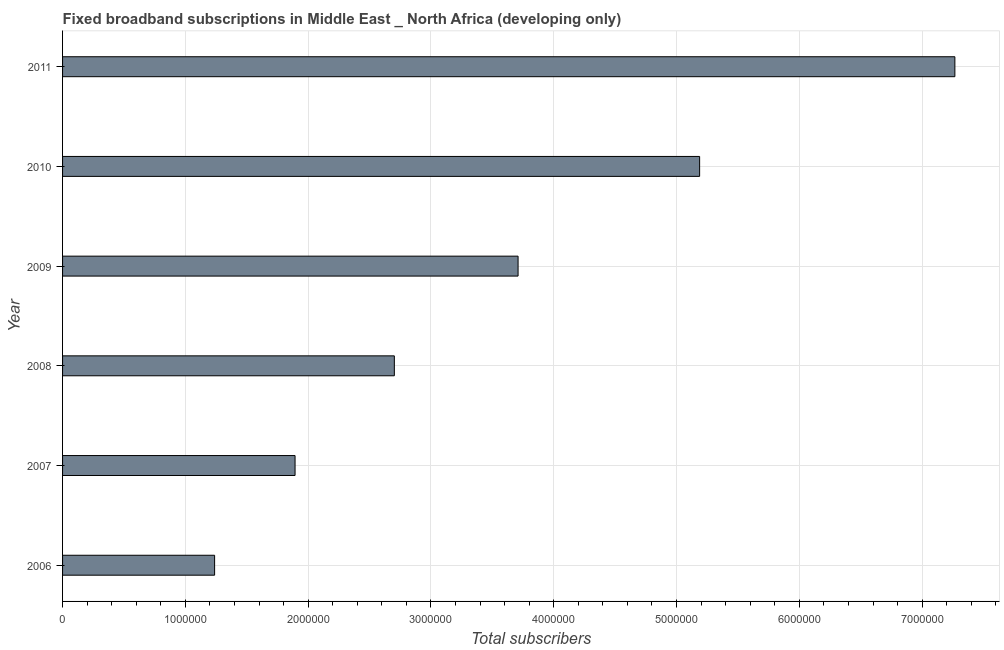Does the graph contain grids?
Your response must be concise. Yes. What is the title of the graph?
Provide a succinct answer. Fixed broadband subscriptions in Middle East _ North Africa (developing only). What is the label or title of the X-axis?
Offer a terse response. Total subscribers. What is the total number of fixed broadband subscriptions in 2011?
Provide a succinct answer. 7.27e+06. Across all years, what is the maximum total number of fixed broadband subscriptions?
Offer a terse response. 7.27e+06. Across all years, what is the minimum total number of fixed broadband subscriptions?
Give a very brief answer. 1.24e+06. What is the sum of the total number of fixed broadband subscriptions?
Offer a very short reply. 2.20e+07. What is the difference between the total number of fixed broadband subscriptions in 2006 and 2007?
Give a very brief answer. -6.55e+05. What is the average total number of fixed broadband subscriptions per year?
Your answer should be compact. 3.67e+06. What is the median total number of fixed broadband subscriptions?
Your answer should be very brief. 3.21e+06. What is the ratio of the total number of fixed broadband subscriptions in 2008 to that in 2009?
Offer a terse response. 0.73. Is the total number of fixed broadband subscriptions in 2007 less than that in 2010?
Offer a very short reply. Yes. What is the difference between the highest and the second highest total number of fixed broadband subscriptions?
Give a very brief answer. 2.08e+06. Is the sum of the total number of fixed broadband subscriptions in 2008 and 2010 greater than the maximum total number of fixed broadband subscriptions across all years?
Provide a short and direct response. Yes. What is the difference between the highest and the lowest total number of fixed broadband subscriptions?
Offer a terse response. 6.03e+06. In how many years, is the total number of fixed broadband subscriptions greater than the average total number of fixed broadband subscriptions taken over all years?
Your response must be concise. 3. Are all the bars in the graph horizontal?
Offer a very short reply. Yes. What is the difference between two consecutive major ticks on the X-axis?
Provide a short and direct response. 1.00e+06. Are the values on the major ticks of X-axis written in scientific E-notation?
Offer a terse response. No. What is the Total subscribers of 2006?
Your answer should be very brief. 1.24e+06. What is the Total subscribers in 2007?
Provide a succinct answer. 1.89e+06. What is the Total subscribers in 2008?
Provide a short and direct response. 2.70e+06. What is the Total subscribers in 2009?
Provide a succinct answer. 3.71e+06. What is the Total subscribers in 2010?
Provide a succinct answer. 5.19e+06. What is the Total subscribers in 2011?
Offer a very short reply. 7.27e+06. What is the difference between the Total subscribers in 2006 and 2007?
Your answer should be very brief. -6.55e+05. What is the difference between the Total subscribers in 2006 and 2008?
Make the answer very short. -1.46e+06. What is the difference between the Total subscribers in 2006 and 2009?
Your response must be concise. -2.47e+06. What is the difference between the Total subscribers in 2006 and 2010?
Offer a terse response. -3.95e+06. What is the difference between the Total subscribers in 2006 and 2011?
Your response must be concise. -6.03e+06. What is the difference between the Total subscribers in 2007 and 2008?
Ensure brevity in your answer.  -8.09e+05. What is the difference between the Total subscribers in 2007 and 2009?
Make the answer very short. -1.82e+06. What is the difference between the Total subscribers in 2007 and 2010?
Keep it short and to the point. -3.29e+06. What is the difference between the Total subscribers in 2007 and 2011?
Make the answer very short. -5.37e+06. What is the difference between the Total subscribers in 2008 and 2009?
Give a very brief answer. -1.01e+06. What is the difference between the Total subscribers in 2008 and 2010?
Your answer should be compact. -2.49e+06. What is the difference between the Total subscribers in 2008 and 2011?
Your response must be concise. -4.56e+06. What is the difference between the Total subscribers in 2009 and 2010?
Your answer should be compact. -1.48e+06. What is the difference between the Total subscribers in 2009 and 2011?
Ensure brevity in your answer.  -3.56e+06. What is the difference between the Total subscribers in 2010 and 2011?
Offer a terse response. -2.08e+06. What is the ratio of the Total subscribers in 2006 to that in 2007?
Offer a terse response. 0.65. What is the ratio of the Total subscribers in 2006 to that in 2008?
Offer a very short reply. 0.46. What is the ratio of the Total subscribers in 2006 to that in 2009?
Provide a succinct answer. 0.33. What is the ratio of the Total subscribers in 2006 to that in 2010?
Offer a very short reply. 0.24. What is the ratio of the Total subscribers in 2006 to that in 2011?
Offer a terse response. 0.17. What is the ratio of the Total subscribers in 2007 to that in 2008?
Your response must be concise. 0.7. What is the ratio of the Total subscribers in 2007 to that in 2009?
Make the answer very short. 0.51. What is the ratio of the Total subscribers in 2007 to that in 2010?
Give a very brief answer. 0.36. What is the ratio of the Total subscribers in 2007 to that in 2011?
Your answer should be compact. 0.26. What is the ratio of the Total subscribers in 2008 to that in 2009?
Provide a short and direct response. 0.73. What is the ratio of the Total subscribers in 2008 to that in 2010?
Provide a succinct answer. 0.52. What is the ratio of the Total subscribers in 2008 to that in 2011?
Keep it short and to the point. 0.37. What is the ratio of the Total subscribers in 2009 to that in 2010?
Your answer should be very brief. 0.71. What is the ratio of the Total subscribers in 2009 to that in 2011?
Make the answer very short. 0.51. What is the ratio of the Total subscribers in 2010 to that in 2011?
Provide a succinct answer. 0.71. 